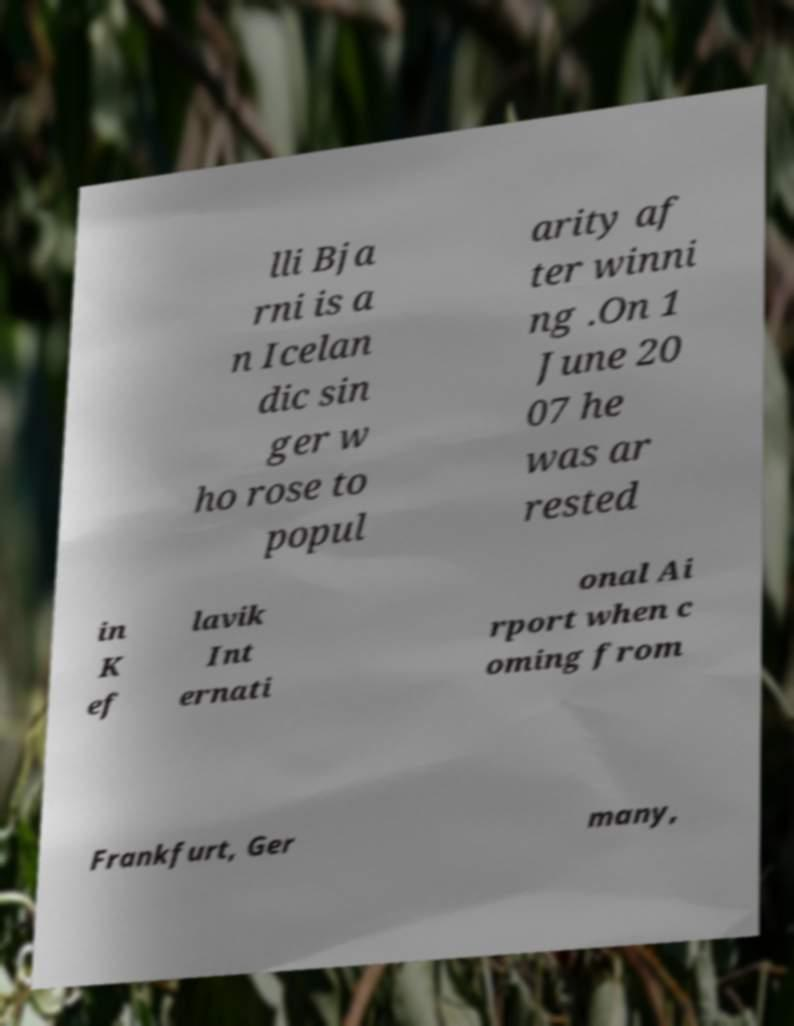Could you extract and type out the text from this image? lli Bja rni is a n Icelan dic sin ger w ho rose to popul arity af ter winni ng .On 1 June 20 07 he was ar rested in K ef lavik Int ernati onal Ai rport when c oming from Frankfurt, Ger many, 